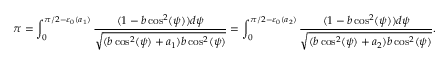<formula> <loc_0><loc_0><loc_500><loc_500>\pi = \int _ { 0 } ^ { \pi / 2 - \varepsilon _ { 0 } ( a _ { 1 } ) } \frac { ( 1 - b \cos ^ { 2 } ( \psi ) ) d \psi } { \sqrt { ( b \cos ^ { 2 } ( \psi ) + a _ { 1 } ) b \cos ^ { 2 } ( \psi ) } } = \int _ { 0 } ^ { \pi / 2 - \varepsilon _ { 0 } ( a _ { 2 } ) } \frac { ( 1 - b \cos ^ { 2 } ( \psi ) ) d \psi } { \sqrt { ( b \cos ^ { 2 } ( \psi ) + a _ { 2 } ) b \cos ^ { 2 } ( \psi ) } } .</formula> 